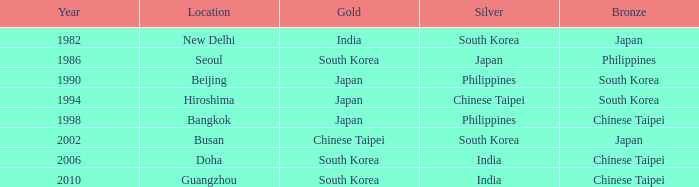Which area holds a silver of japan? Seoul. 